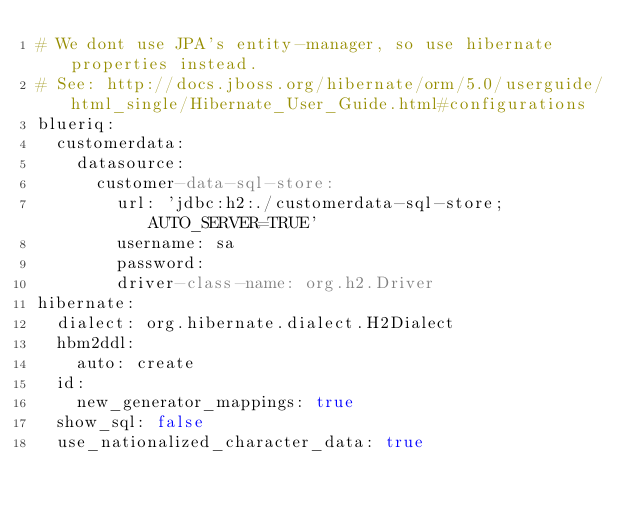<code> <loc_0><loc_0><loc_500><loc_500><_YAML_># We dont use JPA's entity-manager, so use hibernate properties instead.
# See: http://docs.jboss.org/hibernate/orm/5.0/userguide/html_single/Hibernate_User_Guide.html#configurations
blueriq:
  customerdata:
    datasource:
      customer-data-sql-store:
        url: 'jdbc:h2:./customerdata-sql-store;AUTO_SERVER=TRUE'
        username: sa
        password: 
        driver-class-name: org.h2.Driver
hibernate:
  dialect: org.hibernate.dialect.H2Dialect
  hbm2ddl:
    auto: create
  id:
    new_generator_mappings: true
  show_sql: false
  use_nationalized_character_data: true</code> 